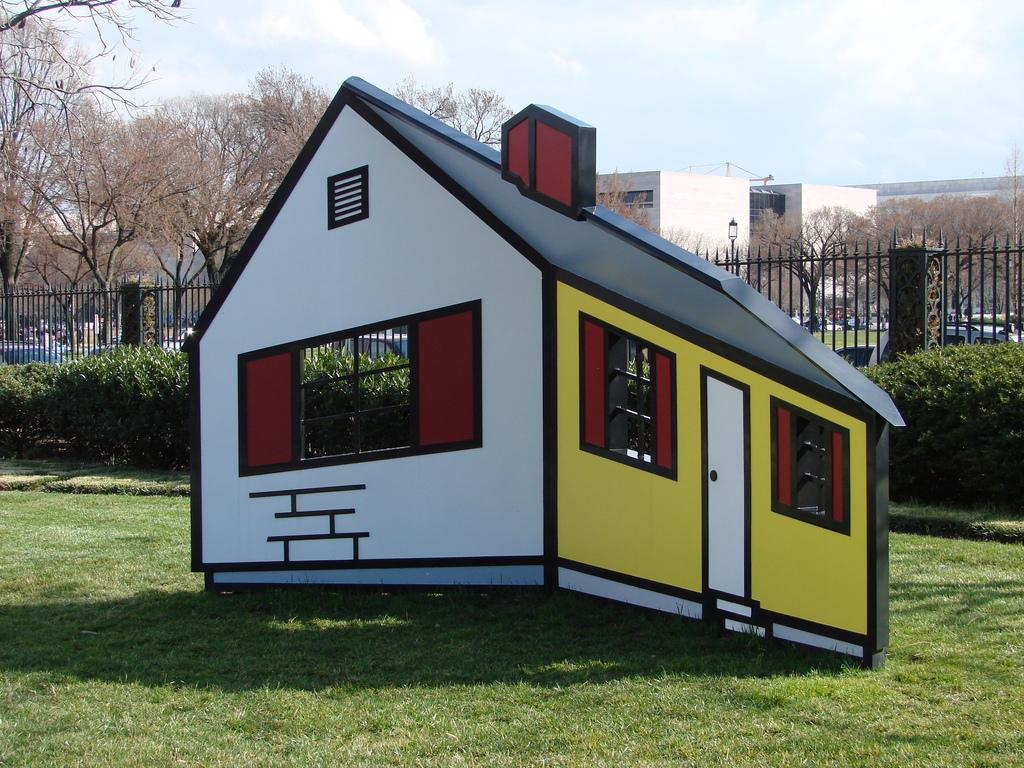What type of structure is present in the image? There is a house in the image. What features can be seen on the house? The house has windows and a door. What type of vegetation is present in the image? There is grass in the image. What type of barrier is present in the image? There is a fence in the image. What type of natural elements are present in the image? There are trees in the image. What type of man-made structures are present in the image? There are buildings in the image. What type of transportation is present in the image? There are vehicles in the image. What can be seen in the background of the image? The sky is visible in the background of the image. What type of weather can be inferred from the image? There are clouds in the sky, suggesting a partly cloudy day. What date is marked on the calendar in the image? There is no calendar present in the image. What caused the house to collapse in the image? There is no indication of a collapsed house or an earthquake in the image. 